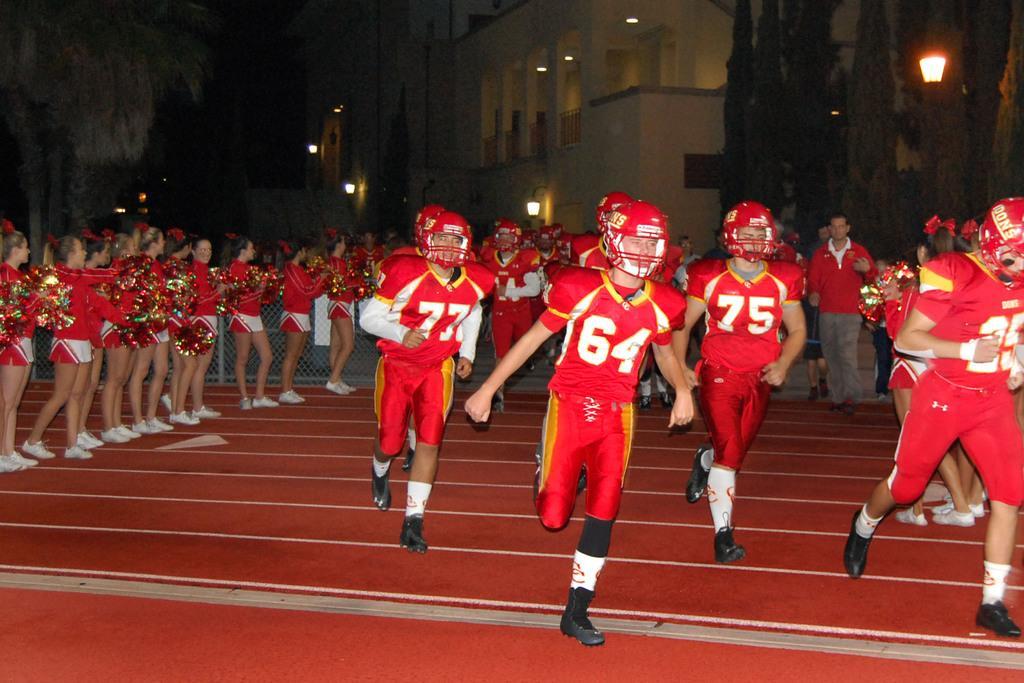Please provide a concise description of this image. In this image it seems like there are few rugby players who are running on the floor. At the bottom there is a red carpet. On the left side there are cheer girls standing on the floor one beside the other by holding the flags. In the background there are buildings with the lights. On the left side top there are trees. 